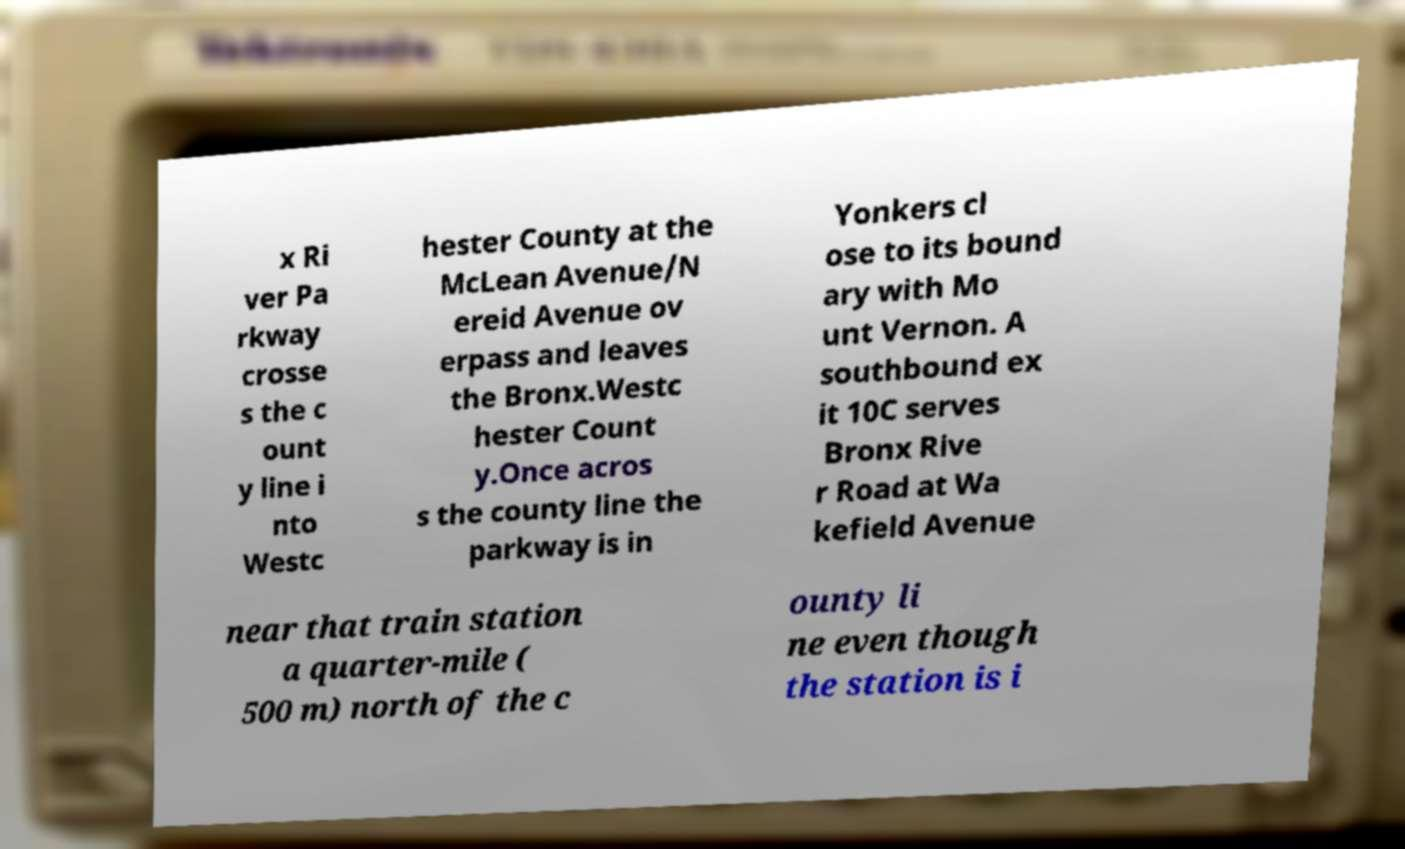Can you accurately transcribe the text from the provided image for me? x Ri ver Pa rkway crosse s the c ount y line i nto Westc hester County at the McLean Avenue/N ereid Avenue ov erpass and leaves the Bronx.Westc hester Count y.Once acros s the county line the parkway is in Yonkers cl ose to its bound ary with Mo unt Vernon. A southbound ex it 10C serves Bronx Rive r Road at Wa kefield Avenue near that train station a quarter-mile ( 500 m) north of the c ounty li ne even though the station is i 